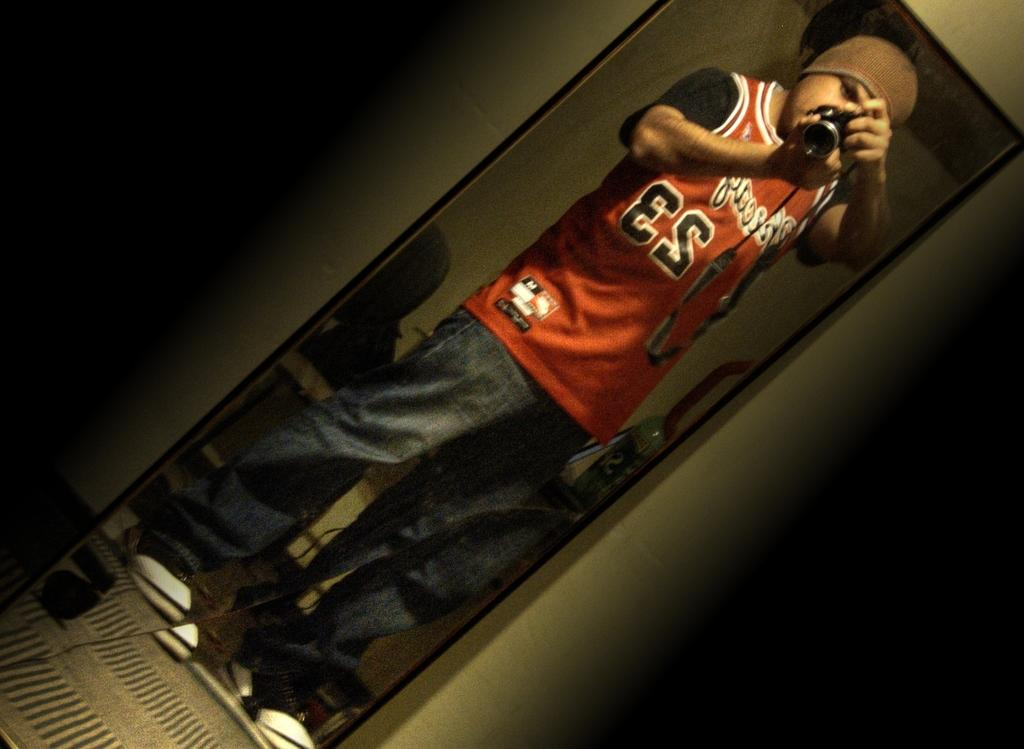Provide a one-sentence caption for the provided image. A man in a red number 23 jersey takes a selfie. 